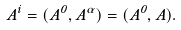<formula> <loc_0><loc_0><loc_500><loc_500>A ^ { i } = ( A ^ { 0 } , A ^ { \alpha } ) = ( A ^ { 0 } , { A } ) .</formula> 